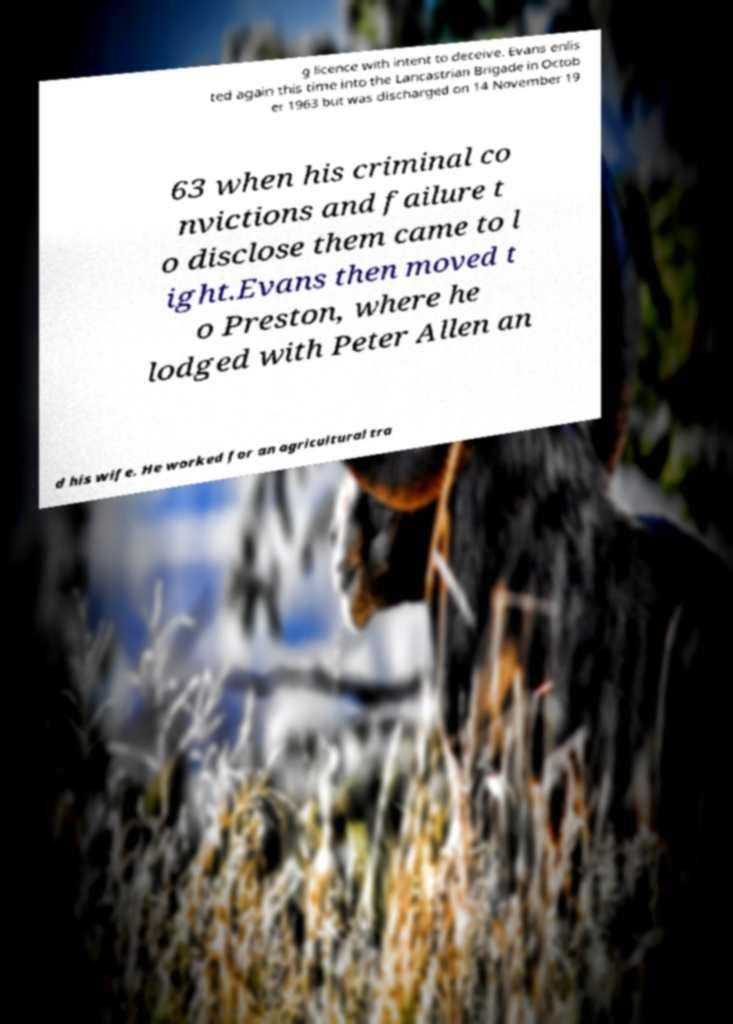I need the written content from this picture converted into text. Can you do that? g licence with intent to deceive. Evans enlis ted again this time into the Lancastrian Brigade in Octob er 1963 but was discharged on 14 November 19 63 when his criminal co nvictions and failure t o disclose them came to l ight.Evans then moved t o Preston, where he lodged with Peter Allen an d his wife. He worked for an agricultural tra 